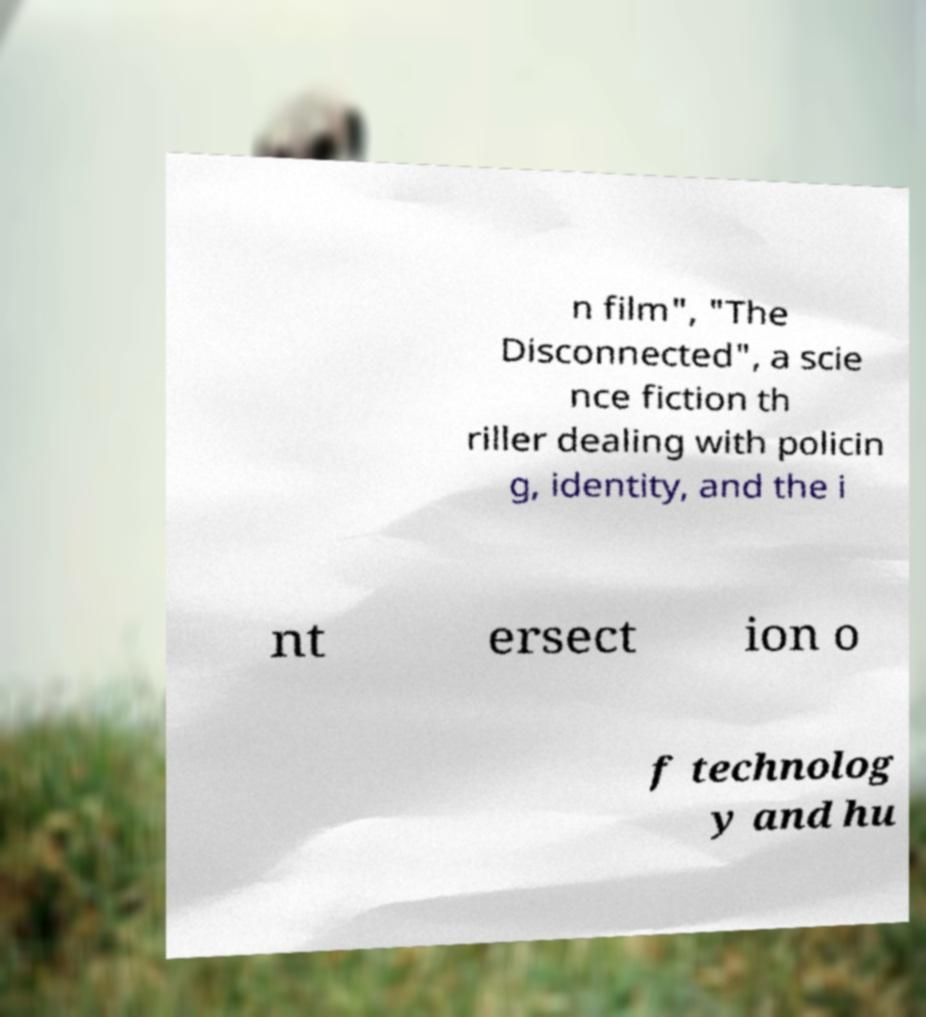Could you extract and type out the text from this image? n film", "The Disconnected", a scie nce fiction th riller dealing with policin g, identity, and the i nt ersect ion o f technolog y and hu 